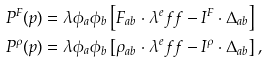Convert formula to latex. <formula><loc_0><loc_0><loc_500><loc_500>P ^ { F } ( p ) & = \lambda \phi _ { a } \phi _ { b } \left [ F _ { a b } \cdot \lambda ^ { e } f f - I ^ { F } \cdot \Delta _ { a b } \right ] \\ P ^ { \rho } ( p ) & = \lambda \phi _ { a } \phi _ { b } \left [ \rho _ { a b } \cdot \lambda ^ { e } f f - I ^ { \rho } \cdot \Delta _ { a b } \right ] ,</formula> 